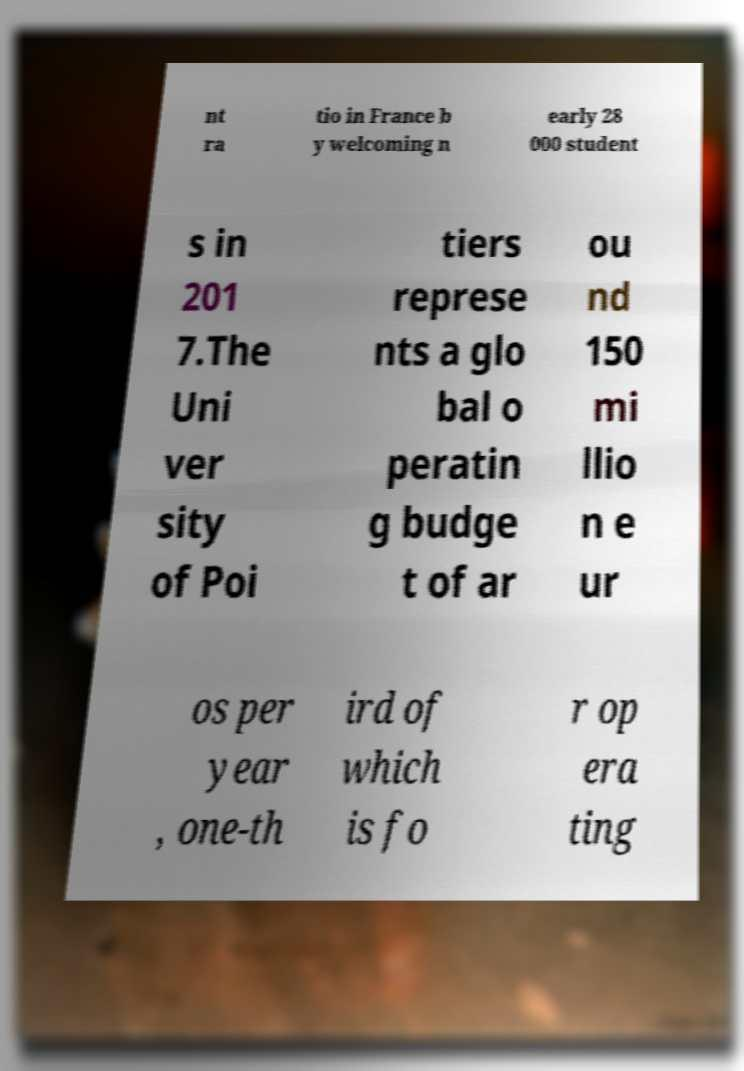There's text embedded in this image that I need extracted. Can you transcribe it verbatim? nt ra tio in France b y welcoming n early 28 000 student s in 201 7.The Uni ver sity of Poi tiers represe nts a glo bal o peratin g budge t of ar ou nd 150 mi llio n e ur os per year , one-th ird of which is fo r op era ting 